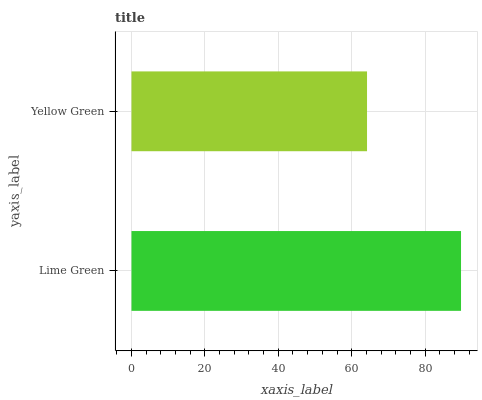Is Yellow Green the minimum?
Answer yes or no. Yes. Is Lime Green the maximum?
Answer yes or no. Yes. Is Yellow Green the maximum?
Answer yes or no. No. Is Lime Green greater than Yellow Green?
Answer yes or no. Yes. Is Yellow Green less than Lime Green?
Answer yes or no. Yes. Is Yellow Green greater than Lime Green?
Answer yes or no. No. Is Lime Green less than Yellow Green?
Answer yes or no. No. Is Lime Green the high median?
Answer yes or no. Yes. Is Yellow Green the low median?
Answer yes or no. Yes. Is Yellow Green the high median?
Answer yes or no. No. Is Lime Green the low median?
Answer yes or no. No. 